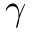<formula> <loc_0><loc_0><loc_500><loc_500>\gamma</formula> 